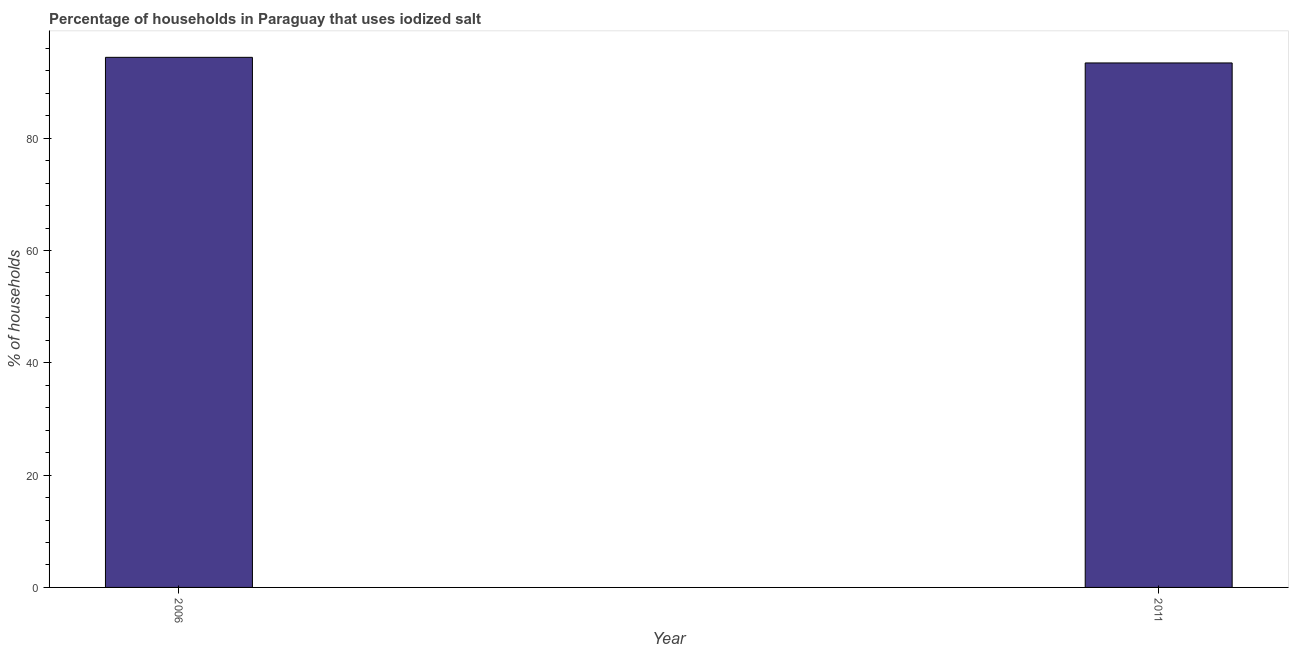Does the graph contain any zero values?
Make the answer very short. No. What is the title of the graph?
Offer a terse response. Percentage of households in Paraguay that uses iodized salt. What is the label or title of the Y-axis?
Your answer should be very brief. % of households. What is the percentage of households where iodized salt is consumed in 2006?
Your response must be concise. 94.4. Across all years, what is the maximum percentage of households where iodized salt is consumed?
Your response must be concise. 94.4. Across all years, what is the minimum percentage of households where iodized salt is consumed?
Ensure brevity in your answer.  93.4. In which year was the percentage of households where iodized salt is consumed maximum?
Give a very brief answer. 2006. In which year was the percentage of households where iodized salt is consumed minimum?
Provide a short and direct response. 2011. What is the sum of the percentage of households where iodized salt is consumed?
Offer a terse response. 187.8. What is the average percentage of households where iodized salt is consumed per year?
Provide a short and direct response. 93.9. What is the median percentage of households where iodized salt is consumed?
Provide a short and direct response. 93.9. Do a majority of the years between 2011 and 2006 (inclusive) have percentage of households where iodized salt is consumed greater than 52 %?
Give a very brief answer. No. How many bars are there?
Make the answer very short. 2. What is the difference between two consecutive major ticks on the Y-axis?
Offer a very short reply. 20. What is the % of households of 2006?
Offer a very short reply. 94.4. What is the % of households in 2011?
Give a very brief answer. 93.4. What is the difference between the % of households in 2006 and 2011?
Give a very brief answer. 1. 